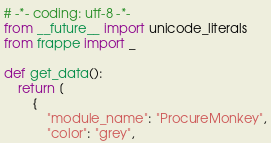Convert code to text. <code><loc_0><loc_0><loc_500><loc_500><_Python_># -*- coding: utf-8 -*-
from __future__ import unicode_literals
from frappe import _

def get_data():
	return [
		{
			"module_name": "ProcureMonkey",
			"color": "grey",</code> 